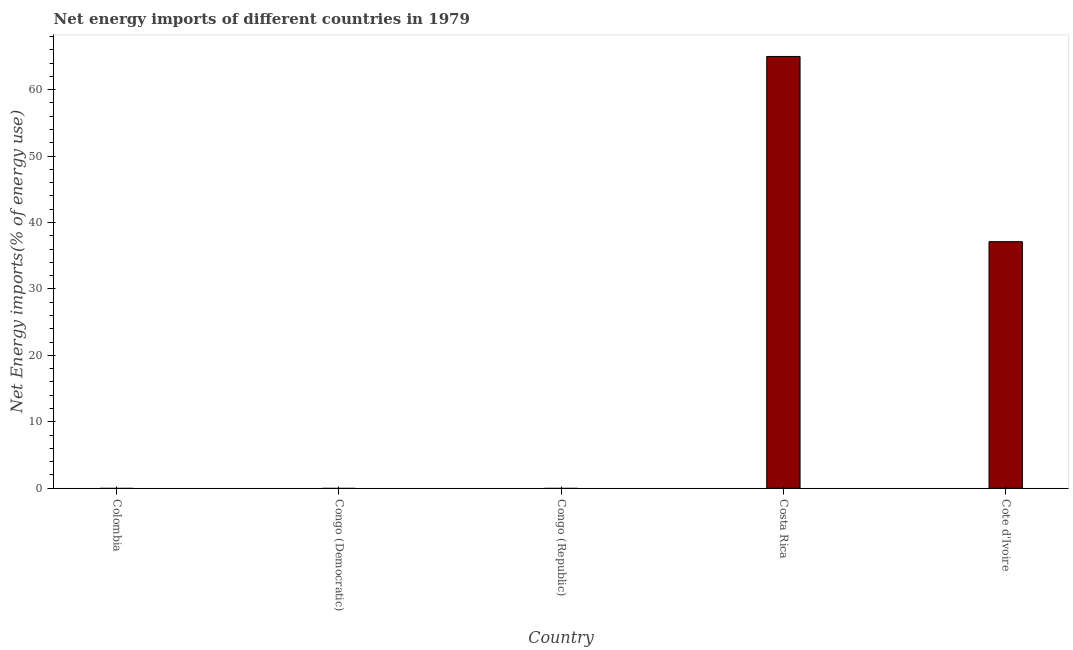Does the graph contain any zero values?
Ensure brevity in your answer.  Yes. What is the title of the graph?
Offer a very short reply. Net energy imports of different countries in 1979. What is the label or title of the Y-axis?
Your response must be concise. Net Energy imports(% of energy use). Across all countries, what is the maximum energy imports?
Your answer should be very brief. 65. Across all countries, what is the minimum energy imports?
Keep it short and to the point. 0. What is the sum of the energy imports?
Your response must be concise. 102.13. What is the average energy imports per country?
Your response must be concise. 20.43. What is the median energy imports?
Make the answer very short. 0. In how many countries, is the energy imports greater than 40 %?
Your response must be concise. 1. What is the difference between the highest and the lowest energy imports?
Your response must be concise. 65. Are the values on the major ticks of Y-axis written in scientific E-notation?
Your answer should be compact. No. What is the Net Energy imports(% of energy use) of Costa Rica?
Offer a very short reply. 65. What is the Net Energy imports(% of energy use) of Cote d'Ivoire?
Ensure brevity in your answer.  37.13. What is the difference between the Net Energy imports(% of energy use) in Costa Rica and Cote d'Ivoire?
Ensure brevity in your answer.  27.88. What is the ratio of the Net Energy imports(% of energy use) in Costa Rica to that in Cote d'Ivoire?
Provide a succinct answer. 1.75. 